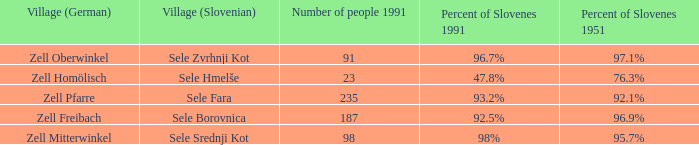Give me the minimum number of people in 1991 with 92.5% of Slovenes in 1991. 187.0. 